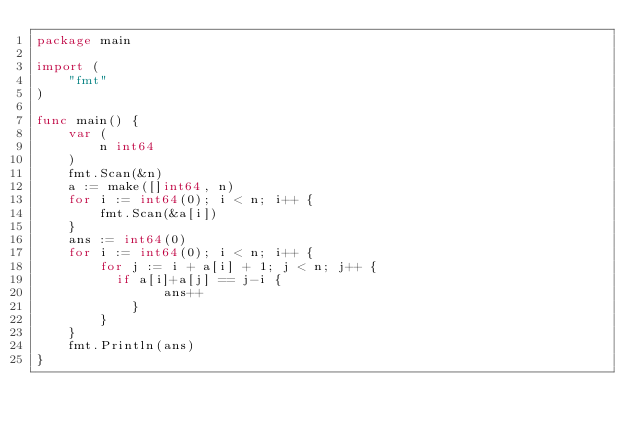<code> <loc_0><loc_0><loc_500><loc_500><_Go_>package main

import (
	"fmt"
)

func main() {
	var (
		n int64
	)
	fmt.Scan(&n)
	a := make([]int64, n)
	for i := int64(0); i < n; i++ {
		fmt.Scan(&a[i])
	}
	ans := int64(0)
	for i := int64(0); i < n; i++ {
		for j := i + a[i] + 1; j < n; j++ {
          if a[i]+a[j] == j-i {
				ans++
			}
		}
	}
	fmt.Println(ans)
}
</code> 